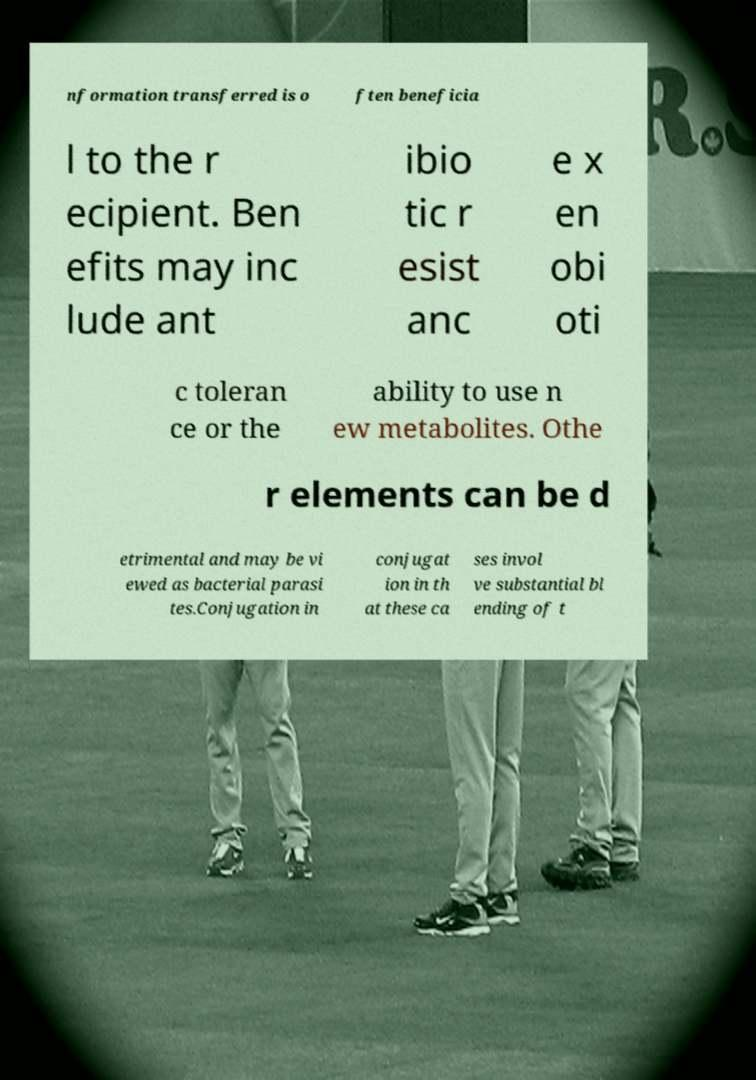There's text embedded in this image that I need extracted. Can you transcribe it verbatim? nformation transferred is o ften beneficia l to the r ecipient. Ben efits may inc lude ant ibio tic r esist anc e x en obi oti c toleran ce or the ability to use n ew metabolites. Othe r elements can be d etrimental and may be vi ewed as bacterial parasi tes.Conjugation in conjugat ion in th at these ca ses invol ve substantial bl ending of t 